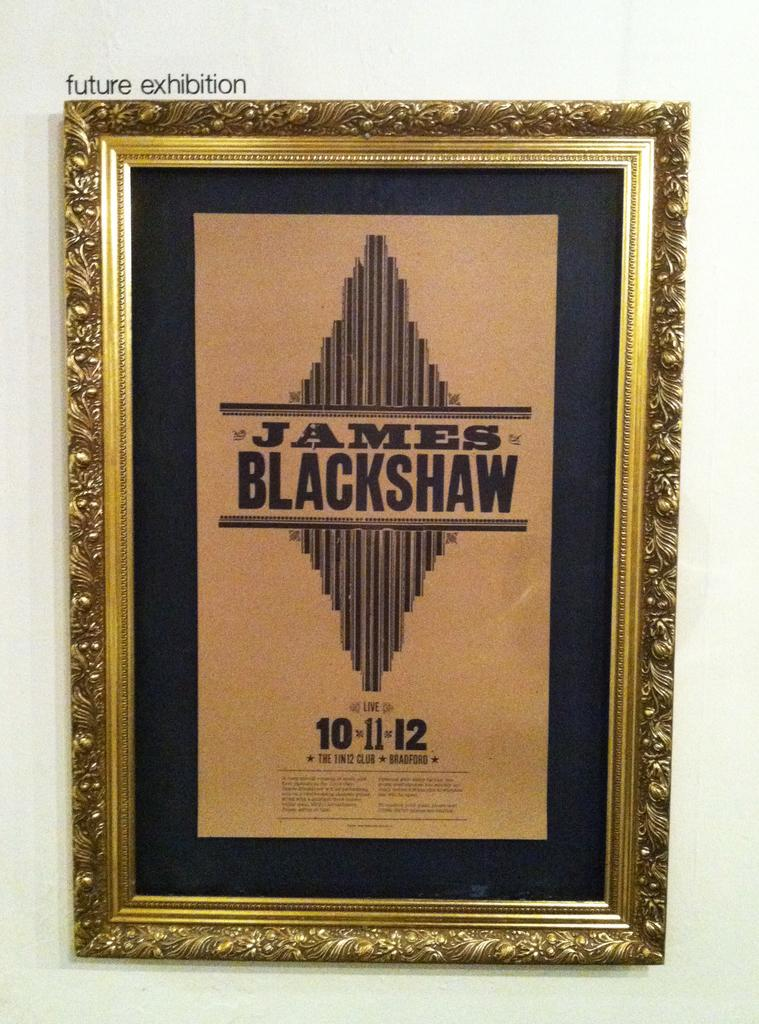<image>
Give a short and clear explanation of the subsequent image. An Art exhibition about James Blackshaw on 10-11-12. 